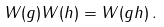Convert formula to latex. <formula><loc_0><loc_0><loc_500><loc_500>W ( g ) W ( h ) = W ( g h ) \, .</formula> 